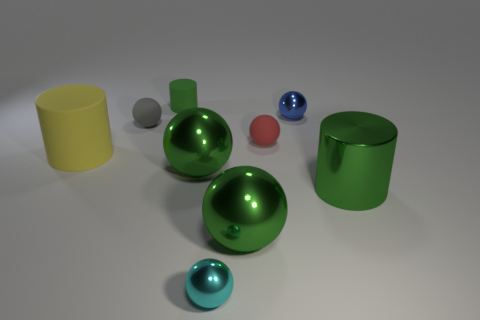What is the color of the big cylinder that is to the right of the small shiny ball that is left of the small metallic thing that is behind the large green cylinder? There appears to be a slight misunderstanding in the provided answer. To the right of the small shiny ball, which is in turn left of the small metallic object behind the large green cylinder, resides another large green cylinder. Thus, there are two large green cylinders in the scene, and the color of the big cylinder directly to the right of the shiny ball is, indeed, green. 